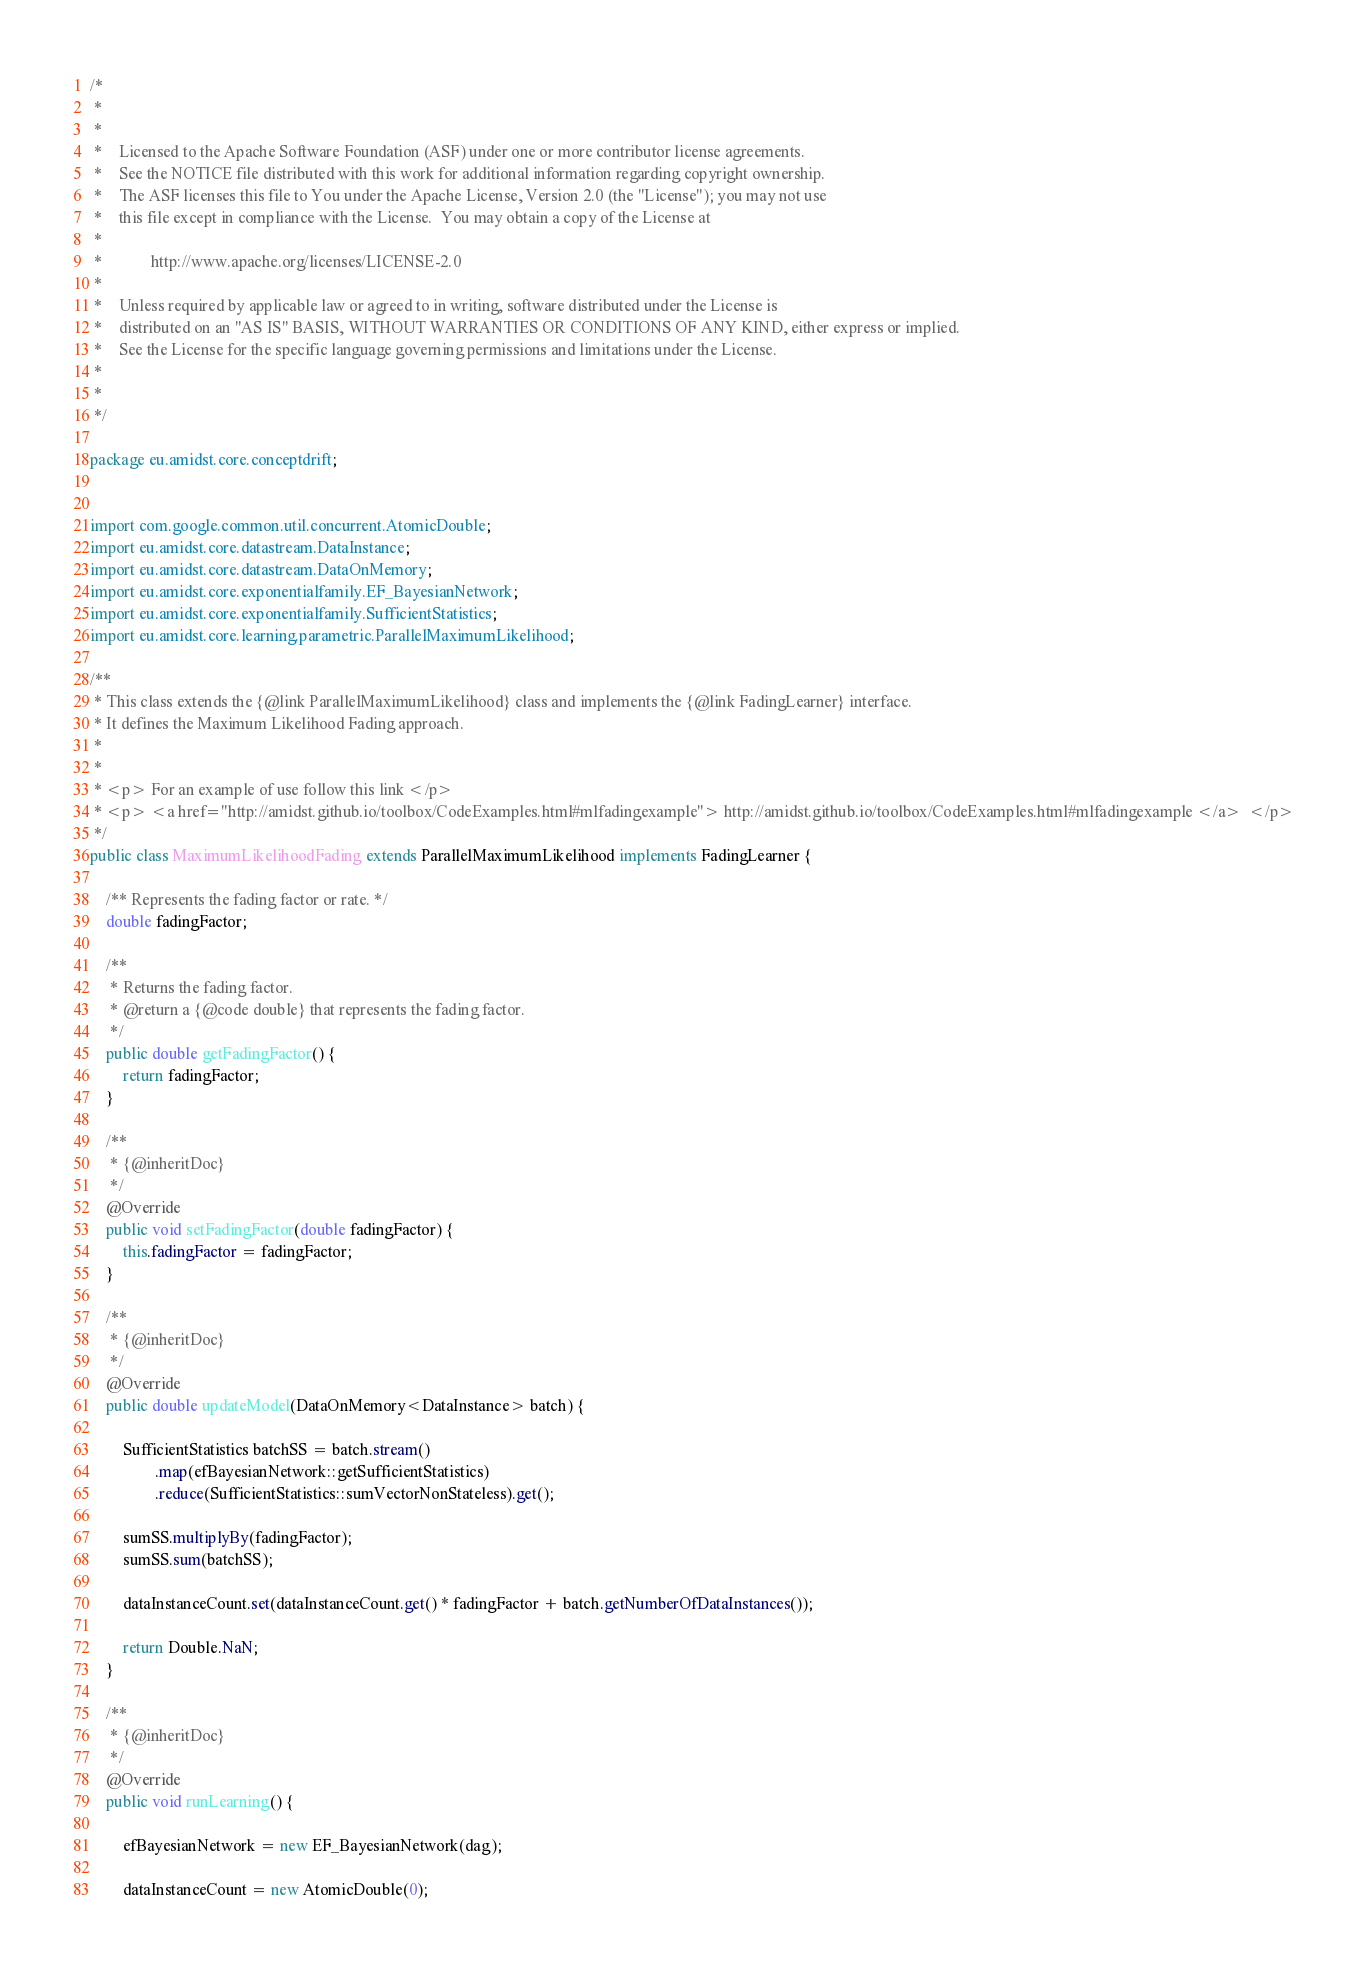<code> <loc_0><loc_0><loc_500><loc_500><_Java_>/*
 *
 *
 *    Licensed to the Apache Software Foundation (ASF) under one or more contributor license agreements.
 *    See the NOTICE file distributed with this work for additional information regarding copyright ownership.
 *    The ASF licenses this file to You under the Apache License, Version 2.0 (the "License"); you may not use
 *    this file except in compliance with the License.  You may obtain a copy of the License at
 *
 *            http://www.apache.org/licenses/LICENSE-2.0
 *
 *    Unless required by applicable law or agreed to in writing, software distributed under the License is
 *    distributed on an "AS IS" BASIS, WITHOUT WARRANTIES OR CONDITIONS OF ANY KIND, either express or implied.
 *    See the License for the specific language governing permissions and limitations under the License.
 *
 *
 */

package eu.amidst.core.conceptdrift;


import com.google.common.util.concurrent.AtomicDouble;
import eu.amidst.core.datastream.DataInstance;
import eu.amidst.core.datastream.DataOnMemory;
import eu.amidst.core.exponentialfamily.EF_BayesianNetwork;
import eu.amidst.core.exponentialfamily.SufficientStatistics;
import eu.amidst.core.learning.parametric.ParallelMaximumLikelihood;

/**
 * This class extends the {@link ParallelMaximumLikelihood} class and implements the {@link FadingLearner} interface.
 * It defines the Maximum Likelihood Fading approach.
 *
 *
 * <p> For an example of use follow this link </p>
 * <p> <a href="http://amidst.github.io/toolbox/CodeExamples.html#mlfadingexample"> http://amidst.github.io/toolbox/CodeExamples.html#mlfadingexample </a>  </p>
 */
public class MaximumLikelihoodFading extends ParallelMaximumLikelihood implements FadingLearner {

    /** Represents the fading factor or rate. */
    double fadingFactor;

    /**
     * Returns the fading factor.
     * @return a {@code double} that represents the fading factor.
     */
    public double getFadingFactor() {
        return fadingFactor;
    }

    /**
     * {@inheritDoc}
     */
    @Override
    public void setFadingFactor(double fadingFactor) {
        this.fadingFactor = fadingFactor;
    }

    /**
     * {@inheritDoc}
     */
    @Override
    public double updateModel(DataOnMemory<DataInstance> batch) {

        SufficientStatistics batchSS = batch.stream()
                .map(efBayesianNetwork::getSufficientStatistics)
                .reduce(SufficientStatistics::sumVectorNonStateless).get();

        sumSS.multiplyBy(fadingFactor);
        sumSS.sum(batchSS);

        dataInstanceCount.set(dataInstanceCount.get() * fadingFactor + batch.getNumberOfDataInstances());

        return Double.NaN;
    }

    /**
     * {@inheritDoc}
     */
    @Override
    public void runLearning() {

        efBayesianNetwork = new EF_BayesianNetwork(dag);

        dataInstanceCount = new AtomicDouble(0);</code> 